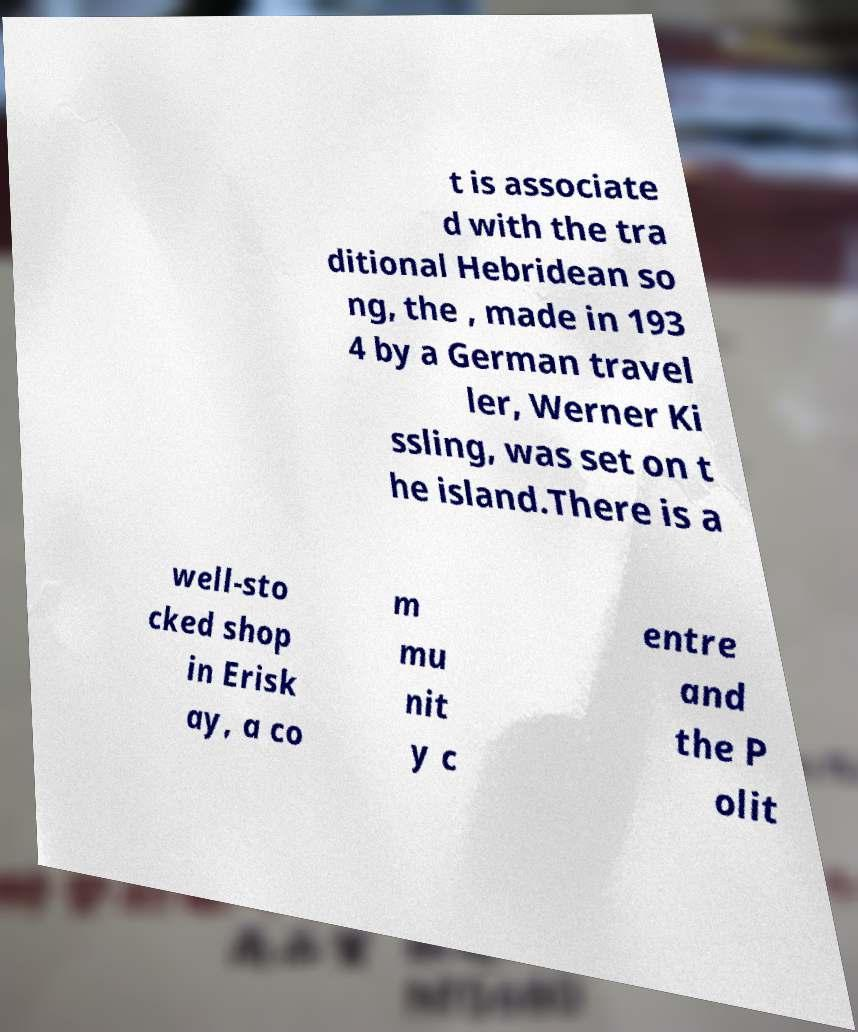Can you accurately transcribe the text from the provided image for me? t is associate d with the tra ditional Hebridean so ng, the , made in 193 4 by a German travel ler, Werner Ki ssling, was set on t he island.There is a well-sto cked shop in Erisk ay, a co m mu nit y c entre and the P olit 